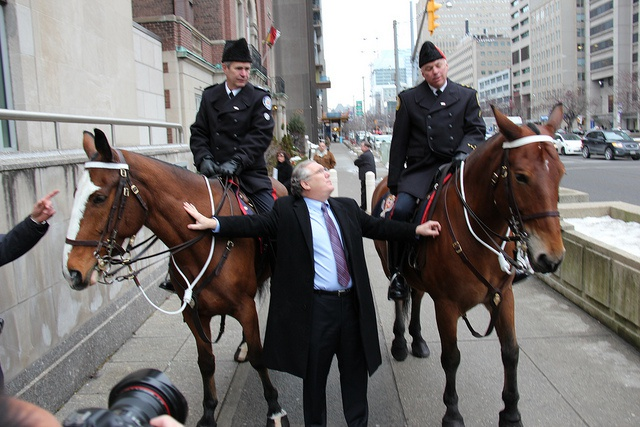Describe the objects in this image and their specific colors. I can see horse in black, maroon, darkgray, and gray tones, people in black, lightgray, lightblue, and gray tones, horse in black, maroon, gray, and brown tones, people in black, gray, and darkgray tones, and people in black and gray tones in this image. 